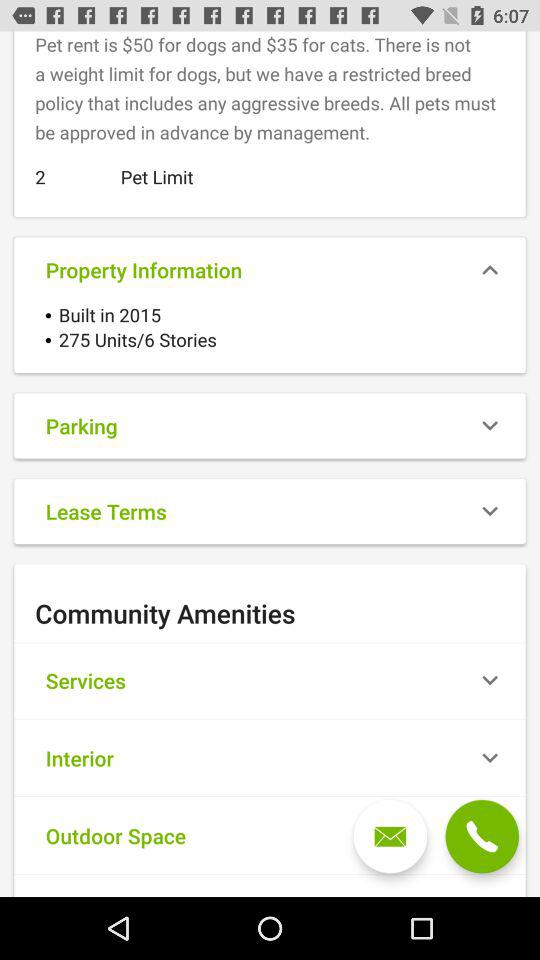What is the number of stories? The number of stories is 6. 